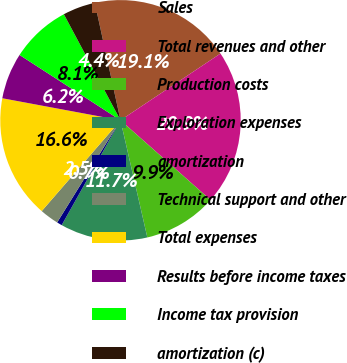<chart> <loc_0><loc_0><loc_500><loc_500><pie_chart><fcel>Sales<fcel>Total revenues and other<fcel>Production costs<fcel>Exploration expenses<fcel>amortization<fcel>Technical support and other<fcel>Total expenses<fcel>Results before income taxes<fcel>Income tax provision<fcel>amortization (c)<nl><fcel>19.06%<fcel>20.9%<fcel>9.88%<fcel>11.72%<fcel>0.7%<fcel>2.54%<fcel>16.56%<fcel>6.21%<fcel>8.05%<fcel>4.38%<nl></chart> 